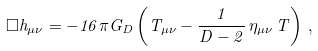Convert formula to latex. <formula><loc_0><loc_0><loc_500><loc_500>\square h _ { \mu \nu } = - 1 6 \pi G _ { D } \left ( T _ { \mu \nu } - \frac { 1 } { D - 2 } \, \eta _ { \mu \nu } \, T \right ) \, ,</formula> 